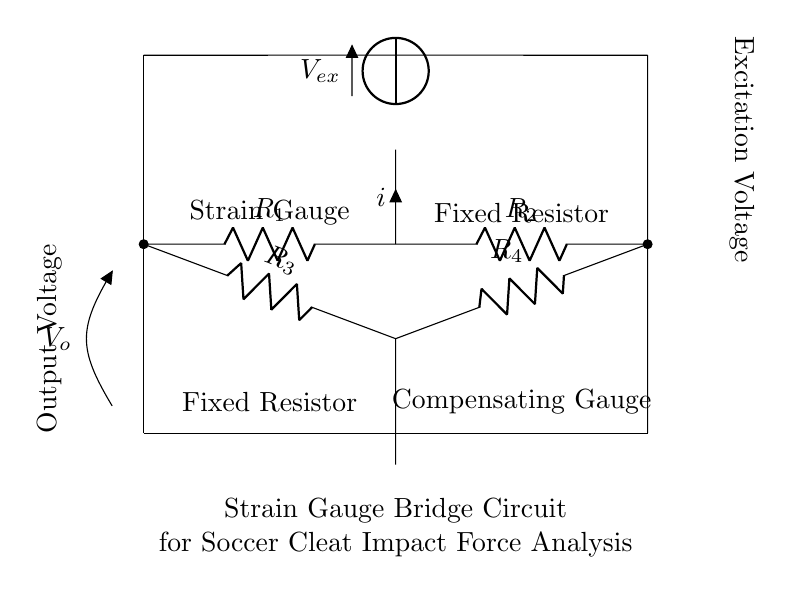What type of circuit is displayed in the diagram? The circuit is a strain gauge bridge circuit, which is used for measuring changes in resistance due to applied force, typically in applications like load cells and pressure sensors.
Answer: Strain gauge bridge What do the resistors represent in this circuit? The resistors represent the strain gauges and fixed resistors used to balance the bridge circuit and measure the variations in resistance when forces are applied to the cleats.
Answer: Strain gauges and fixed resistors What is the excitation voltage denoted as? The excitation voltage in the circuit is represented by the symbol V subscript ex, indicating the voltage supplied to the bridge circuit for operation.
Answer: V ex How many resistors are used in the circuit? The circuit has a total of four resistors, which are labeled as R subscript 1, R subscript 2, R subscript 3, and R subscript 4, each serving a specific function in the bridge configuration.
Answer: Four What does the output voltage measure in this circuit? The output voltage (denoted as V subscript o) measures the differential voltage that indicates the difference in resistance caused by the applied impact force on the cleats.
Answer: Impact force difference What is the role of the compensating gauge in the strain gauge bridge? The compensating gauge helps to balance environmental effects and any mechanical changes that could affect the readings, thereby improving measurement accuracy.
Answer: Balance environmental effects What indicates the current direction in the circuit? The arrow labeled with the symbol i indicates the direction of current flow through the circuit, signifying the movement of charge from high to low potential.
Answer: The arrow labeled with i 